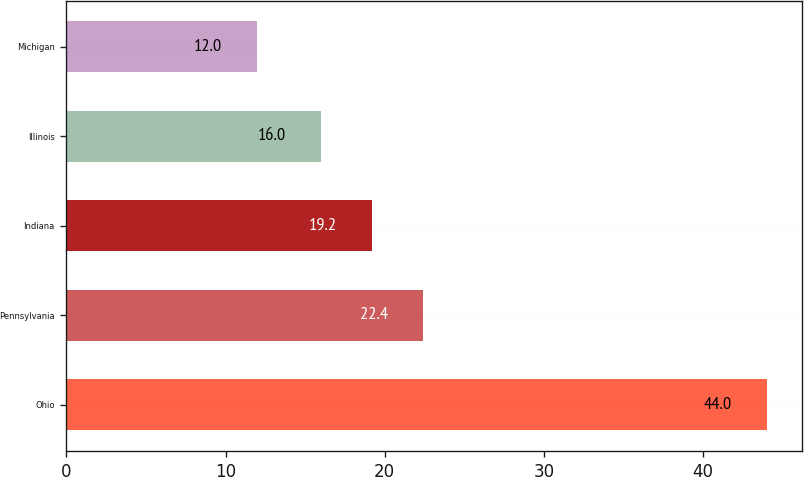<chart> <loc_0><loc_0><loc_500><loc_500><bar_chart><fcel>Ohio<fcel>Pennsylvania<fcel>Indiana<fcel>Illinois<fcel>Michigan<nl><fcel>44<fcel>22.4<fcel>19.2<fcel>16<fcel>12<nl></chart> 